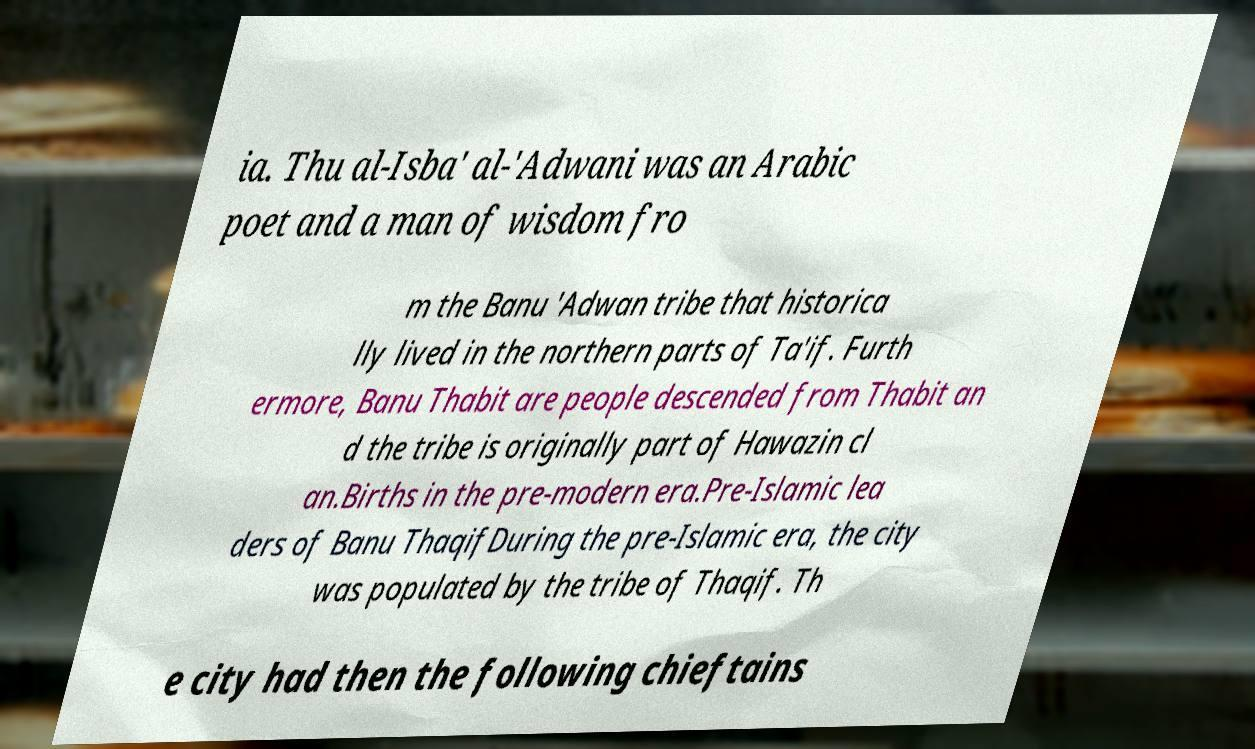What messages or text are displayed in this image? I need them in a readable, typed format. ia. Thu al-Isba' al-'Adwani was an Arabic poet and a man of wisdom fro m the Banu 'Adwan tribe that historica lly lived in the northern parts of Ta'if. Furth ermore, Banu Thabit are people descended from Thabit an d the tribe is originally part of Hawazin cl an.Births in the pre-modern era.Pre-Islamic lea ders of Banu ThaqifDuring the pre-Islamic era, the city was populated by the tribe of Thaqif. Th e city had then the following chieftains 